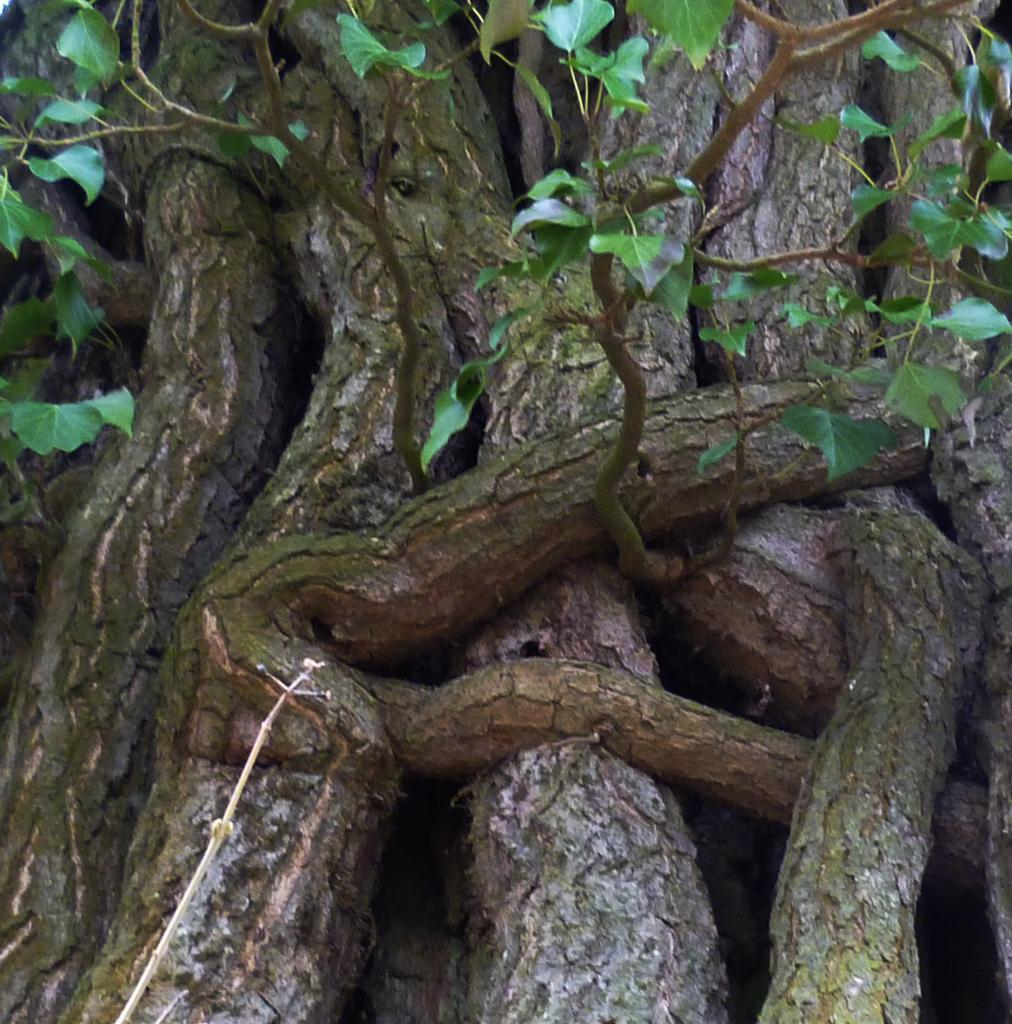What type of vegetation is visible in the image? The image contains the stems and branches of trees. What is the color of the leaves on the trees in the image? The trees in the image have green leaves. What type of skirt is being worn by the tree in the image? There is no skirt present in the image, as it features trees with branches and green leaves. 